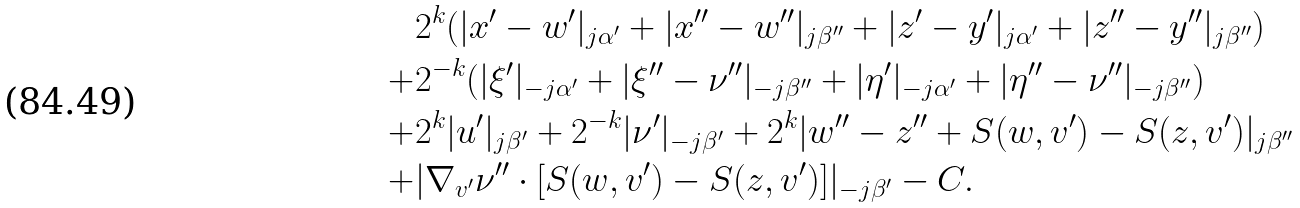<formula> <loc_0><loc_0><loc_500><loc_500>& 2 ^ { k } ( | x ^ { \prime } - w ^ { \prime } | _ { j \alpha ^ { \prime } } + | x ^ { \prime \prime } - w ^ { \prime \prime } | _ { j \beta ^ { \prime \prime } } + | z ^ { \prime } - y ^ { \prime } | _ { j \alpha ^ { \prime } } + | z ^ { \prime \prime } - y ^ { \prime \prime } | _ { j \beta ^ { \prime \prime } } ) \\ + & 2 ^ { - k } ( | \xi ^ { \prime } | _ { - j \alpha ^ { \prime } } + | \xi ^ { \prime \prime } - \nu ^ { \prime \prime } | _ { - j \beta ^ { \prime \prime } } + | \eta ^ { \prime } | _ { - j \alpha ^ { \prime } } + | \eta ^ { \prime \prime } - \nu ^ { \prime \prime } | _ { - j \beta ^ { \prime \prime } } ) \\ + & 2 ^ { k } | u ^ { \prime } | _ { j \beta ^ { \prime } } + 2 ^ { - k } | \nu ^ { \prime } | _ { - j \beta ^ { \prime } } + 2 ^ { k } | w ^ { \prime \prime } - z ^ { \prime \prime } + S ( w , v ^ { \prime } ) - S ( z , v ^ { \prime } ) | _ { j \beta ^ { \prime \prime } } \\ + & | \nabla _ { v ^ { \prime } } \nu ^ { \prime \prime } \cdot [ S ( w , v ^ { \prime } ) - S ( z , v ^ { \prime } ) ] | _ { - j \beta ^ { \prime } } - C .</formula> 